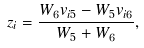Convert formula to latex. <formula><loc_0><loc_0><loc_500><loc_500>z _ { i } = \frac { W _ { 6 } v _ { i 5 } - W _ { 5 } v _ { i 6 } } { W _ { 5 } + W _ { 6 } } ,</formula> 